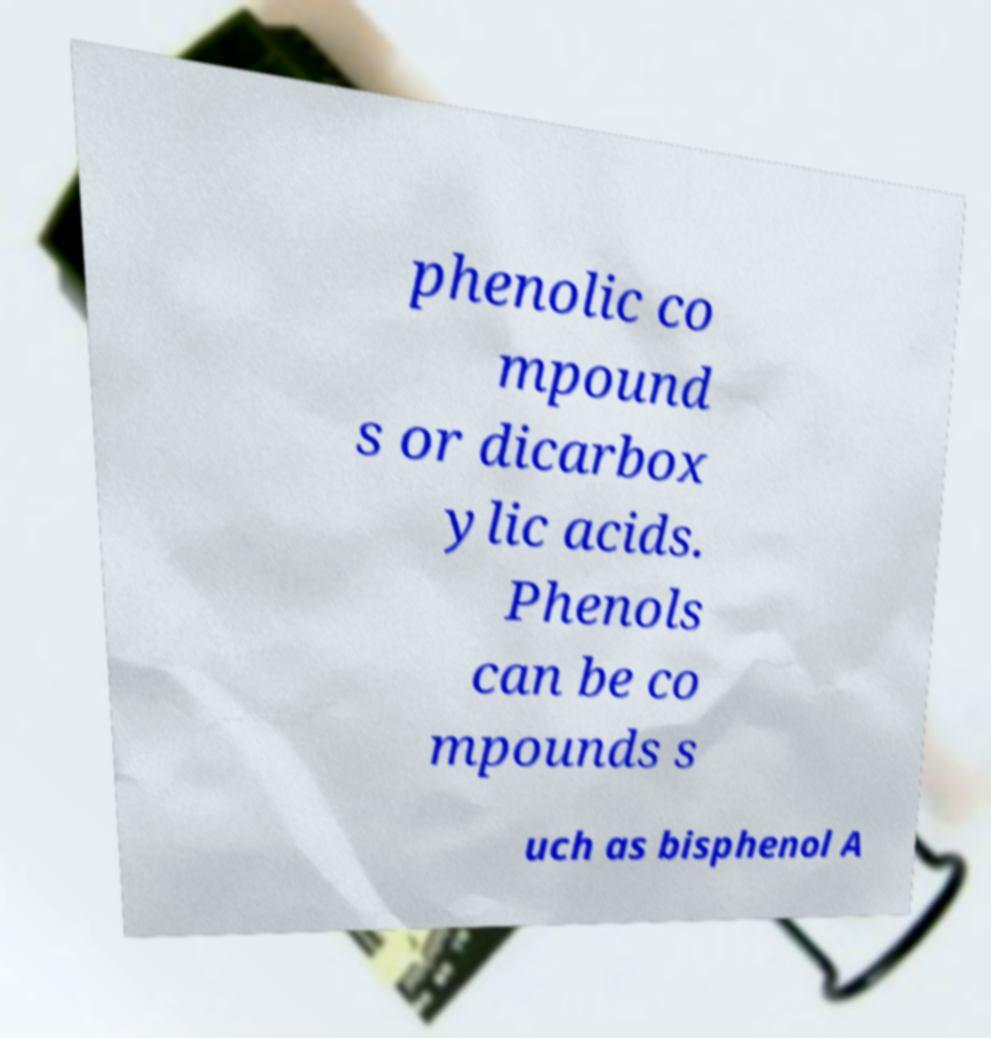Please identify and transcribe the text found in this image. phenolic co mpound s or dicarbox ylic acids. Phenols can be co mpounds s uch as bisphenol A 